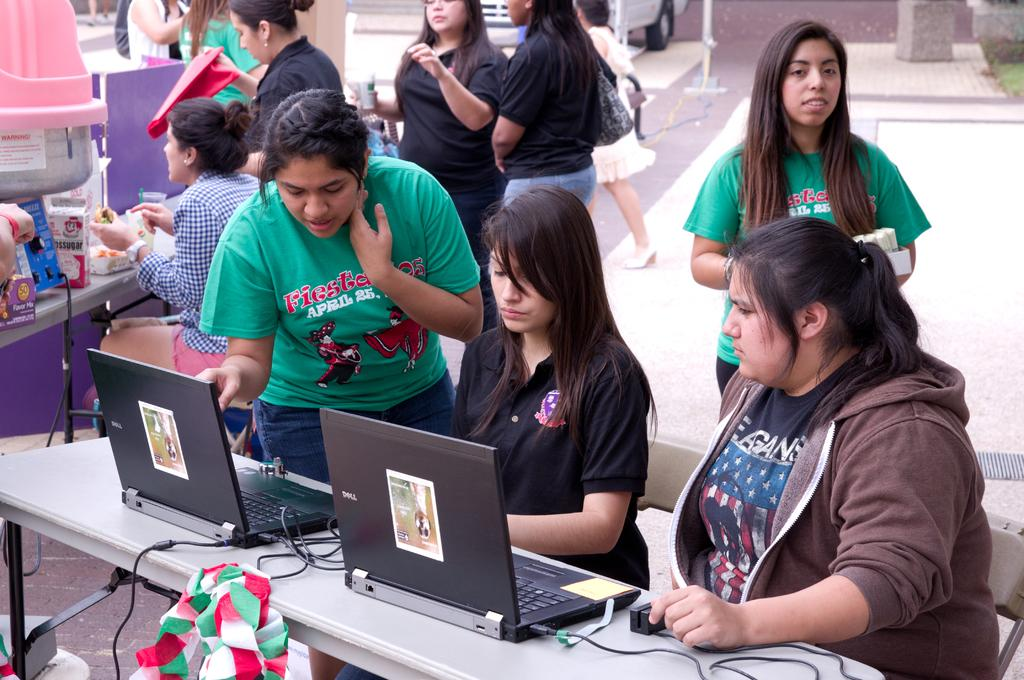<image>
Describe the image concisely. Several young females working on black DELL laptops 